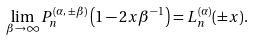Convert formula to latex. <formula><loc_0><loc_0><loc_500><loc_500>\lim _ { \beta \to \infty } P _ { n } ^ { ( \alpha , \, \pm \beta ) } \left ( 1 - 2 x \beta ^ { - 1 } \right ) = L _ { n } ^ { ( \alpha ) } ( \pm x ) .</formula> 